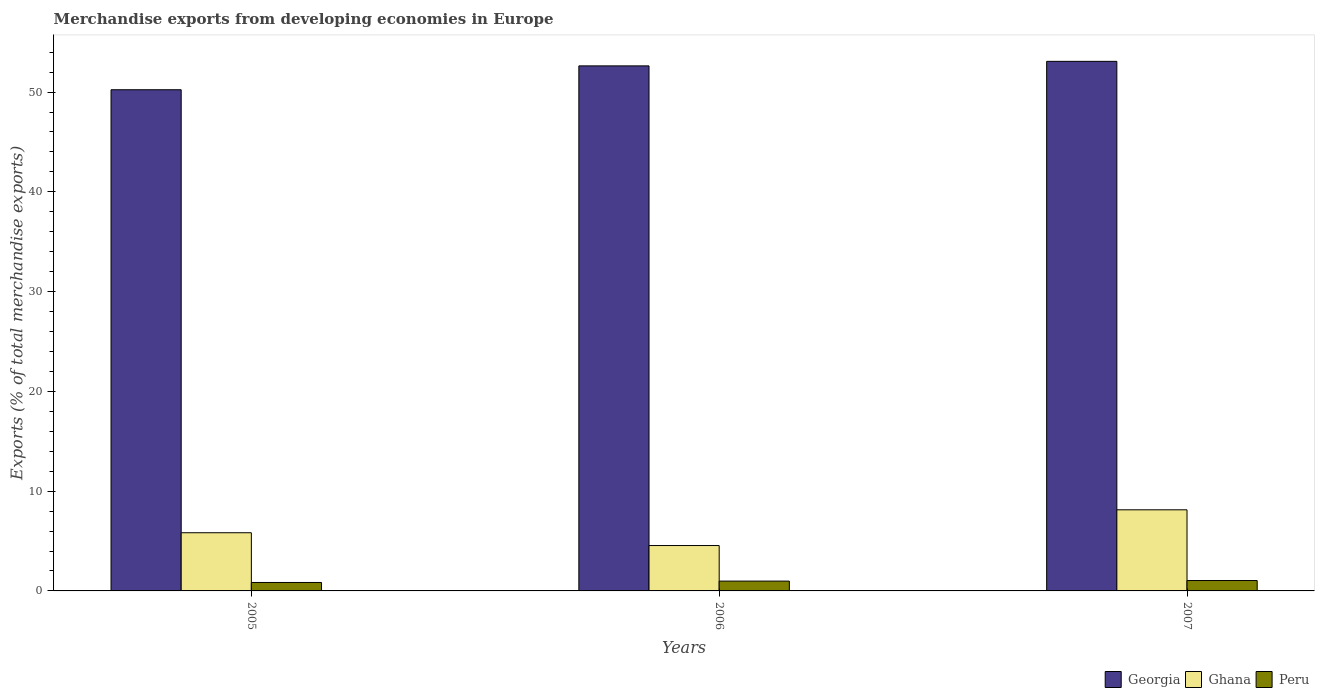How many different coloured bars are there?
Offer a very short reply. 3. How many groups of bars are there?
Offer a very short reply. 3. What is the label of the 2nd group of bars from the left?
Give a very brief answer. 2006. In how many cases, is the number of bars for a given year not equal to the number of legend labels?
Your answer should be compact. 0. What is the percentage of total merchandise exports in Georgia in 2007?
Give a very brief answer. 53.08. Across all years, what is the maximum percentage of total merchandise exports in Ghana?
Give a very brief answer. 8.13. Across all years, what is the minimum percentage of total merchandise exports in Georgia?
Your response must be concise. 50.23. In which year was the percentage of total merchandise exports in Peru maximum?
Your response must be concise. 2007. In which year was the percentage of total merchandise exports in Georgia minimum?
Give a very brief answer. 2005. What is the total percentage of total merchandise exports in Ghana in the graph?
Your response must be concise. 18.51. What is the difference between the percentage of total merchandise exports in Ghana in 2006 and that in 2007?
Give a very brief answer. -3.58. What is the difference between the percentage of total merchandise exports in Ghana in 2007 and the percentage of total merchandise exports in Georgia in 2005?
Your answer should be very brief. -42.1. What is the average percentage of total merchandise exports in Peru per year?
Make the answer very short. 0.96. In the year 2005, what is the difference between the percentage of total merchandise exports in Georgia and percentage of total merchandise exports in Peru?
Make the answer very short. 49.39. In how many years, is the percentage of total merchandise exports in Georgia greater than 28 %?
Provide a short and direct response. 3. What is the ratio of the percentage of total merchandise exports in Peru in 2005 to that in 2007?
Offer a terse response. 0.81. Is the percentage of total merchandise exports in Peru in 2005 less than that in 2006?
Keep it short and to the point. Yes. Is the difference between the percentage of total merchandise exports in Georgia in 2005 and 2007 greater than the difference between the percentage of total merchandise exports in Peru in 2005 and 2007?
Your answer should be compact. No. What is the difference between the highest and the second highest percentage of total merchandise exports in Peru?
Provide a succinct answer. 0.06. What is the difference between the highest and the lowest percentage of total merchandise exports in Ghana?
Provide a succinct answer. 3.58. What does the 2nd bar from the left in 2006 represents?
Make the answer very short. Ghana. Is it the case that in every year, the sum of the percentage of total merchandise exports in Georgia and percentage of total merchandise exports in Peru is greater than the percentage of total merchandise exports in Ghana?
Provide a succinct answer. Yes. Are all the bars in the graph horizontal?
Your answer should be very brief. No. What is the difference between two consecutive major ticks on the Y-axis?
Provide a short and direct response. 10. Are the values on the major ticks of Y-axis written in scientific E-notation?
Your answer should be compact. No. Does the graph contain any zero values?
Give a very brief answer. No. Where does the legend appear in the graph?
Your answer should be very brief. Bottom right. How are the legend labels stacked?
Your answer should be compact. Horizontal. What is the title of the graph?
Provide a short and direct response. Merchandise exports from developing economies in Europe. What is the label or title of the X-axis?
Make the answer very short. Years. What is the label or title of the Y-axis?
Your answer should be very brief. Exports (% of total merchandise exports). What is the Exports (% of total merchandise exports) in Georgia in 2005?
Keep it short and to the point. 50.23. What is the Exports (% of total merchandise exports) of Ghana in 2005?
Give a very brief answer. 5.83. What is the Exports (% of total merchandise exports) in Peru in 2005?
Your answer should be compact. 0.85. What is the Exports (% of total merchandise exports) in Georgia in 2006?
Ensure brevity in your answer.  52.62. What is the Exports (% of total merchandise exports) of Ghana in 2006?
Your response must be concise. 4.55. What is the Exports (% of total merchandise exports) of Peru in 2006?
Give a very brief answer. 0.98. What is the Exports (% of total merchandise exports) in Georgia in 2007?
Your response must be concise. 53.08. What is the Exports (% of total merchandise exports) of Ghana in 2007?
Provide a short and direct response. 8.13. What is the Exports (% of total merchandise exports) of Peru in 2007?
Your response must be concise. 1.04. Across all years, what is the maximum Exports (% of total merchandise exports) of Georgia?
Ensure brevity in your answer.  53.08. Across all years, what is the maximum Exports (% of total merchandise exports) of Ghana?
Your response must be concise. 8.13. Across all years, what is the maximum Exports (% of total merchandise exports) in Peru?
Your answer should be compact. 1.04. Across all years, what is the minimum Exports (% of total merchandise exports) of Georgia?
Your answer should be very brief. 50.23. Across all years, what is the minimum Exports (% of total merchandise exports) of Ghana?
Offer a very short reply. 4.55. Across all years, what is the minimum Exports (% of total merchandise exports) in Peru?
Give a very brief answer. 0.85. What is the total Exports (% of total merchandise exports) in Georgia in the graph?
Your response must be concise. 155.93. What is the total Exports (% of total merchandise exports) in Ghana in the graph?
Make the answer very short. 18.51. What is the total Exports (% of total merchandise exports) of Peru in the graph?
Offer a very short reply. 2.87. What is the difference between the Exports (% of total merchandise exports) of Georgia in 2005 and that in 2006?
Keep it short and to the point. -2.39. What is the difference between the Exports (% of total merchandise exports) of Ghana in 2005 and that in 2006?
Ensure brevity in your answer.  1.28. What is the difference between the Exports (% of total merchandise exports) in Peru in 2005 and that in 2006?
Your answer should be compact. -0.14. What is the difference between the Exports (% of total merchandise exports) in Georgia in 2005 and that in 2007?
Provide a short and direct response. -2.84. What is the difference between the Exports (% of total merchandise exports) in Ghana in 2005 and that in 2007?
Make the answer very short. -2.3. What is the difference between the Exports (% of total merchandise exports) in Peru in 2005 and that in 2007?
Keep it short and to the point. -0.19. What is the difference between the Exports (% of total merchandise exports) in Georgia in 2006 and that in 2007?
Your answer should be compact. -0.45. What is the difference between the Exports (% of total merchandise exports) in Ghana in 2006 and that in 2007?
Your answer should be compact. -3.58. What is the difference between the Exports (% of total merchandise exports) of Peru in 2006 and that in 2007?
Provide a short and direct response. -0.06. What is the difference between the Exports (% of total merchandise exports) of Georgia in 2005 and the Exports (% of total merchandise exports) of Ghana in 2006?
Your answer should be very brief. 45.68. What is the difference between the Exports (% of total merchandise exports) of Georgia in 2005 and the Exports (% of total merchandise exports) of Peru in 2006?
Ensure brevity in your answer.  49.25. What is the difference between the Exports (% of total merchandise exports) in Ghana in 2005 and the Exports (% of total merchandise exports) in Peru in 2006?
Provide a short and direct response. 4.85. What is the difference between the Exports (% of total merchandise exports) in Georgia in 2005 and the Exports (% of total merchandise exports) in Ghana in 2007?
Ensure brevity in your answer.  42.1. What is the difference between the Exports (% of total merchandise exports) in Georgia in 2005 and the Exports (% of total merchandise exports) in Peru in 2007?
Give a very brief answer. 49.19. What is the difference between the Exports (% of total merchandise exports) of Ghana in 2005 and the Exports (% of total merchandise exports) of Peru in 2007?
Make the answer very short. 4.79. What is the difference between the Exports (% of total merchandise exports) of Georgia in 2006 and the Exports (% of total merchandise exports) of Ghana in 2007?
Ensure brevity in your answer.  44.49. What is the difference between the Exports (% of total merchandise exports) in Georgia in 2006 and the Exports (% of total merchandise exports) in Peru in 2007?
Your answer should be very brief. 51.58. What is the difference between the Exports (% of total merchandise exports) in Ghana in 2006 and the Exports (% of total merchandise exports) in Peru in 2007?
Give a very brief answer. 3.51. What is the average Exports (% of total merchandise exports) of Georgia per year?
Provide a succinct answer. 51.98. What is the average Exports (% of total merchandise exports) of Ghana per year?
Ensure brevity in your answer.  6.17. In the year 2005, what is the difference between the Exports (% of total merchandise exports) of Georgia and Exports (% of total merchandise exports) of Ghana?
Ensure brevity in your answer.  44.4. In the year 2005, what is the difference between the Exports (% of total merchandise exports) in Georgia and Exports (% of total merchandise exports) in Peru?
Offer a terse response. 49.39. In the year 2005, what is the difference between the Exports (% of total merchandise exports) in Ghana and Exports (% of total merchandise exports) in Peru?
Provide a short and direct response. 4.99. In the year 2006, what is the difference between the Exports (% of total merchandise exports) of Georgia and Exports (% of total merchandise exports) of Ghana?
Your answer should be compact. 48.07. In the year 2006, what is the difference between the Exports (% of total merchandise exports) in Georgia and Exports (% of total merchandise exports) in Peru?
Make the answer very short. 51.64. In the year 2006, what is the difference between the Exports (% of total merchandise exports) of Ghana and Exports (% of total merchandise exports) of Peru?
Keep it short and to the point. 3.56. In the year 2007, what is the difference between the Exports (% of total merchandise exports) in Georgia and Exports (% of total merchandise exports) in Ghana?
Your response must be concise. 44.95. In the year 2007, what is the difference between the Exports (% of total merchandise exports) of Georgia and Exports (% of total merchandise exports) of Peru?
Provide a succinct answer. 52.04. In the year 2007, what is the difference between the Exports (% of total merchandise exports) of Ghana and Exports (% of total merchandise exports) of Peru?
Provide a short and direct response. 7.09. What is the ratio of the Exports (% of total merchandise exports) in Georgia in 2005 to that in 2006?
Offer a very short reply. 0.95. What is the ratio of the Exports (% of total merchandise exports) of Ghana in 2005 to that in 2006?
Your response must be concise. 1.28. What is the ratio of the Exports (% of total merchandise exports) in Peru in 2005 to that in 2006?
Offer a terse response. 0.86. What is the ratio of the Exports (% of total merchandise exports) in Georgia in 2005 to that in 2007?
Make the answer very short. 0.95. What is the ratio of the Exports (% of total merchandise exports) in Ghana in 2005 to that in 2007?
Ensure brevity in your answer.  0.72. What is the ratio of the Exports (% of total merchandise exports) in Peru in 2005 to that in 2007?
Provide a short and direct response. 0.81. What is the ratio of the Exports (% of total merchandise exports) in Georgia in 2006 to that in 2007?
Your answer should be compact. 0.99. What is the ratio of the Exports (% of total merchandise exports) in Ghana in 2006 to that in 2007?
Keep it short and to the point. 0.56. What is the ratio of the Exports (% of total merchandise exports) in Peru in 2006 to that in 2007?
Give a very brief answer. 0.95. What is the difference between the highest and the second highest Exports (% of total merchandise exports) of Georgia?
Offer a very short reply. 0.45. What is the difference between the highest and the second highest Exports (% of total merchandise exports) of Ghana?
Your answer should be compact. 2.3. What is the difference between the highest and the second highest Exports (% of total merchandise exports) of Peru?
Keep it short and to the point. 0.06. What is the difference between the highest and the lowest Exports (% of total merchandise exports) of Georgia?
Your response must be concise. 2.84. What is the difference between the highest and the lowest Exports (% of total merchandise exports) of Ghana?
Offer a very short reply. 3.58. What is the difference between the highest and the lowest Exports (% of total merchandise exports) of Peru?
Provide a short and direct response. 0.19. 